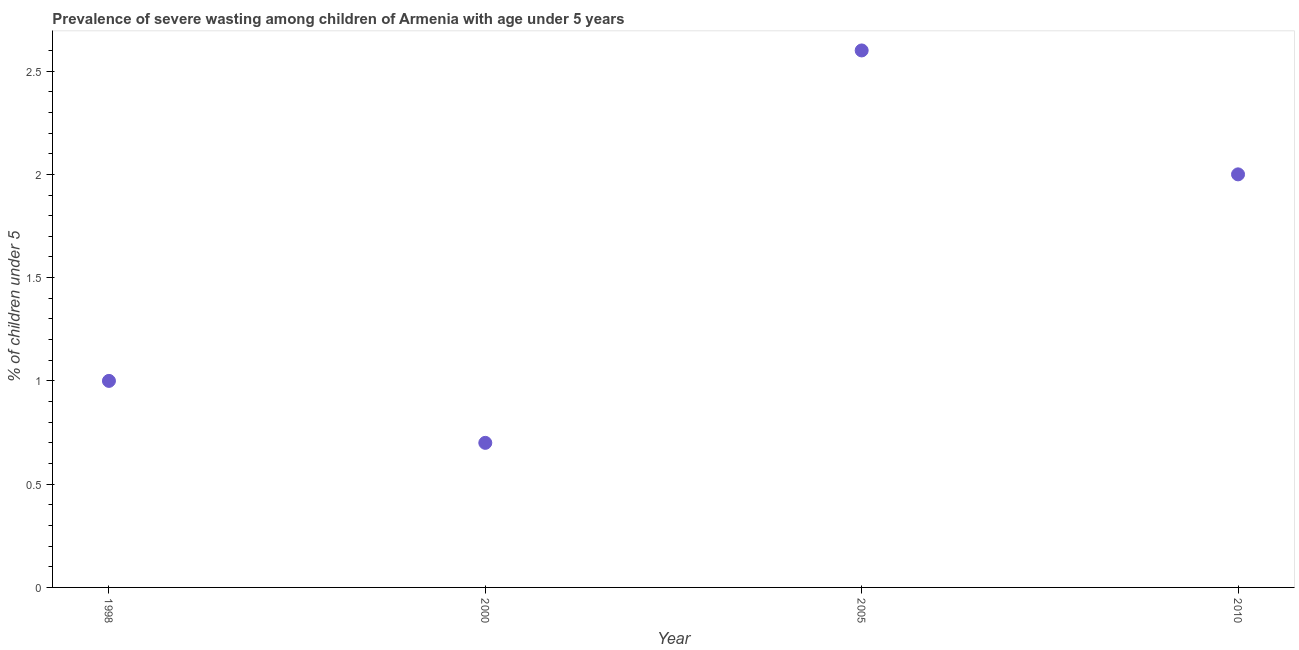What is the prevalence of severe wasting in 2005?
Provide a short and direct response. 2.6. Across all years, what is the maximum prevalence of severe wasting?
Provide a short and direct response. 2.6. Across all years, what is the minimum prevalence of severe wasting?
Offer a terse response. 0.7. In which year was the prevalence of severe wasting maximum?
Offer a very short reply. 2005. In which year was the prevalence of severe wasting minimum?
Offer a very short reply. 2000. What is the sum of the prevalence of severe wasting?
Your answer should be very brief. 6.3. What is the difference between the prevalence of severe wasting in 1998 and 2005?
Offer a terse response. -1.6. What is the average prevalence of severe wasting per year?
Provide a succinct answer. 1.57. In how many years, is the prevalence of severe wasting greater than 1.6 %?
Provide a short and direct response. 2. Do a majority of the years between 2010 and 2005 (inclusive) have prevalence of severe wasting greater than 1.2 %?
Offer a very short reply. No. What is the ratio of the prevalence of severe wasting in 1998 to that in 2000?
Ensure brevity in your answer.  1.43. Is the prevalence of severe wasting in 2000 less than that in 2010?
Offer a terse response. Yes. Is the difference between the prevalence of severe wasting in 2005 and 2010 greater than the difference between any two years?
Your answer should be very brief. No. What is the difference between the highest and the second highest prevalence of severe wasting?
Ensure brevity in your answer.  0.6. Is the sum of the prevalence of severe wasting in 2000 and 2005 greater than the maximum prevalence of severe wasting across all years?
Keep it short and to the point. Yes. What is the difference between the highest and the lowest prevalence of severe wasting?
Make the answer very short. 1.9. Does the prevalence of severe wasting monotonically increase over the years?
Give a very brief answer. No. How many dotlines are there?
Provide a succinct answer. 1. How many years are there in the graph?
Keep it short and to the point. 4. What is the difference between two consecutive major ticks on the Y-axis?
Your answer should be compact. 0.5. What is the title of the graph?
Make the answer very short. Prevalence of severe wasting among children of Armenia with age under 5 years. What is the label or title of the X-axis?
Your response must be concise. Year. What is the label or title of the Y-axis?
Provide a succinct answer.  % of children under 5. What is the  % of children under 5 in 2000?
Make the answer very short. 0.7. What is the  % of children under 5 in 2005?
Your response must be concise. 2.6. What is the  % of children under 5 in 2010?
Ensure brevity in your answer.  2. What is the difference between the  % of children under 5 in 1998 and 2005?
Offer a very short reply. -1.6. What is the difference between the  % of children under 5 in 1998 and 2010?
Provide a short and direct response. -1. What is the difference between the  % of children under 5 in 2000 and 2005?
Provide a succinct answer. -1.9. What is the ratio of the  % of children under 5 in 1998 to that in 2000?
Give a very brief answer. 1.43. What is the ratio of the  % of children under 5 in 1998 to that in 2005?
Keep it short and to the point. 0.39. What is the ratio of the  % of children under 5 in 2000 to that in 2005?
Your response must be concise. 0.27. What is the ratio of the  % of children under 5 in 2000 to that in 2010?
Ensure brevity in your answer.  0.35. What is the ratio of the  % of children under 5 in 2005 to that in 2010?
Keep it short and to the point. 1.3. 